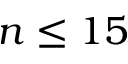Convert formula to latex. <formula><loc_0><loc_0><loc_500><loc_500>n \leq 1 5</formula> 